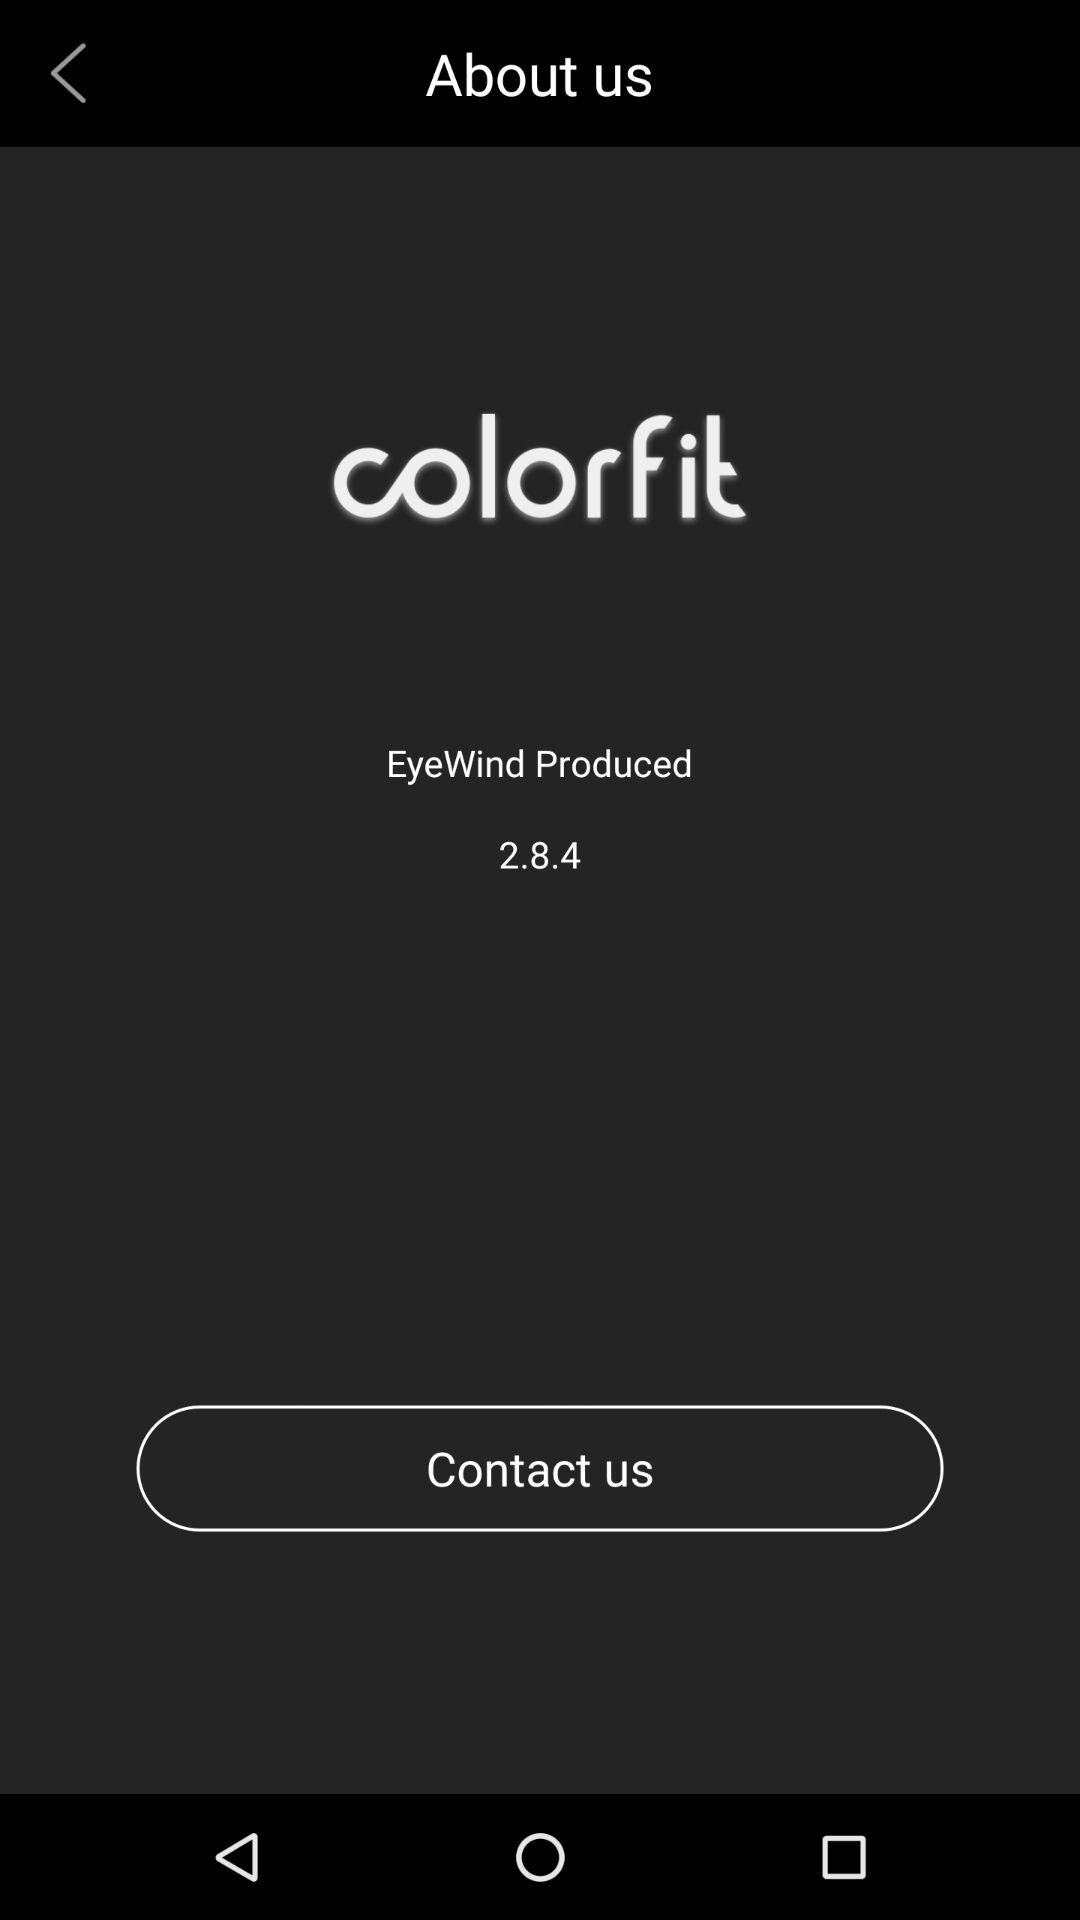What is the version of the application? The version is 2.8.4. 